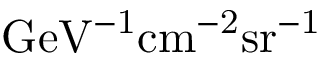Convert formula to latex. <formula><loc_0><loc_0><loc_500><loc_500>G e V ^ { - 1 } c m ^ { - 2 } s r ^ { - 1 }</formula> 